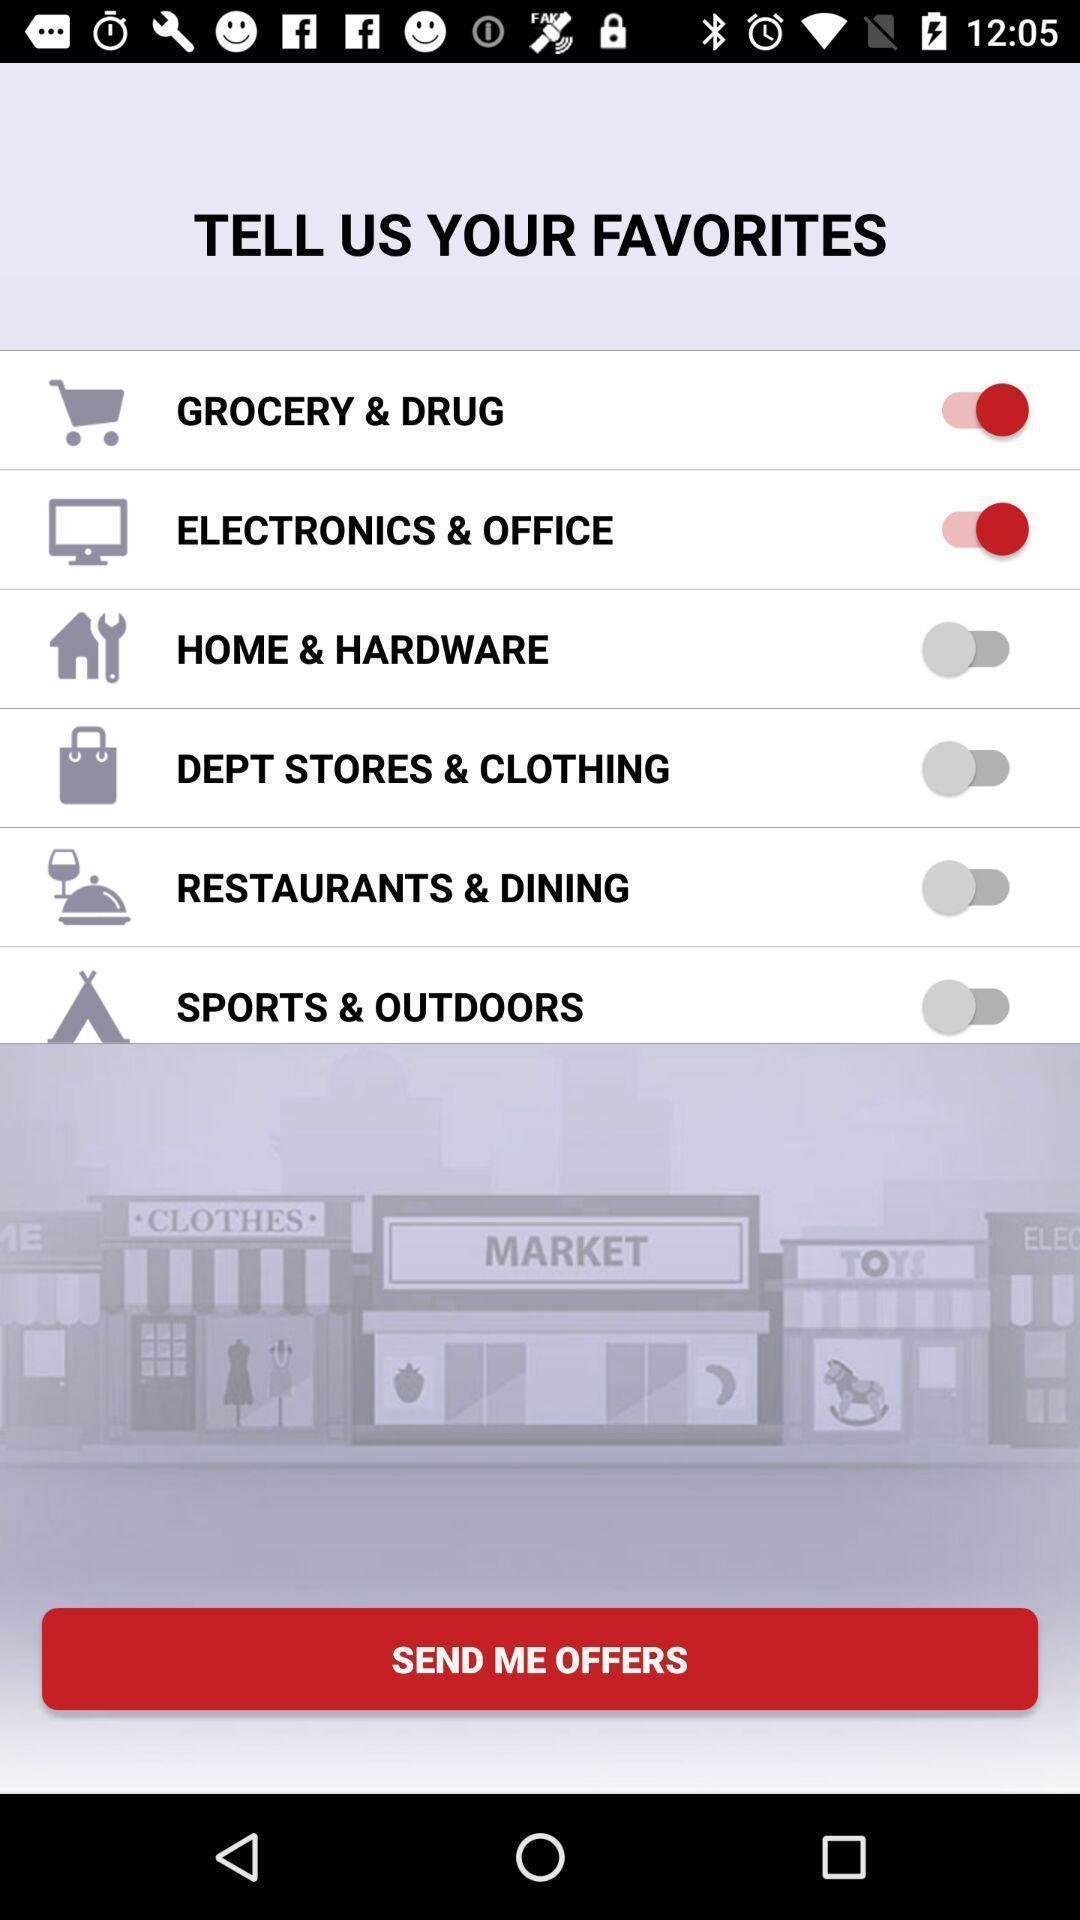Provide a textual representation of this image. Pop up showing send me offers in an shopping app. 